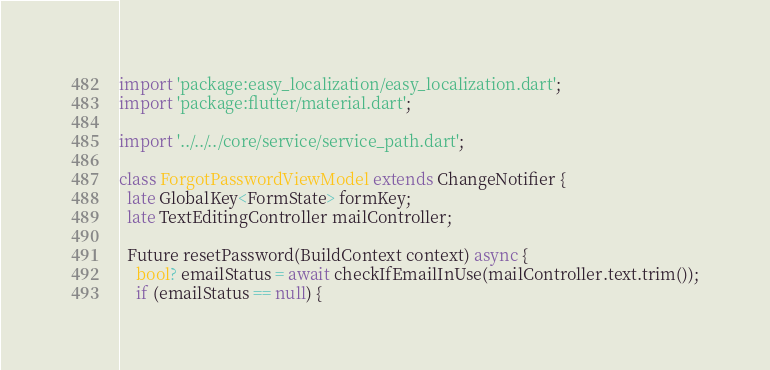<code> <loc_0><loc_0><loc_500><loc_500><_Dart_>import 'package:easy_localization/easy_localization.dart';
import 'package:flutter/material.dart';

import '../../../core/service/service_path.dart';

class ForgotPasswordViewModel extends ChangeNotifier {
  late GlobalKey<FormState> formKey;
  late TextEditingController mailController;

  Future resetPassword(BuildContext context) async {
    bool? emailStatus = await checkIfEmailInUse(mailController.text.trim());
    if (emailStatus == null) {</code> 